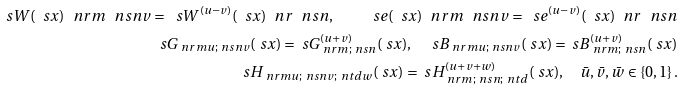Convert formula to latex. <formula><loc_0><loc_0><loc_500><loc_500>\ s W ( \ s x ) _ { \ } n r m ^ { \ } n s n v = \ s W ^ { ( u - v ) } ( \ s x ) _ { \ } n r ^ { \ } n s n , \quad \ s e ( \ s x ) _ { \ } n r m ^ { \ } n s n v = \ s e ^ { ( u - v ) } ( \ s x ) _ { \ } n r ^ { \ } n s n \\ \ s G _ { \ n r m u ; \ n s n v } ( \ s x ) = \ s G _ { \ n r m ; \ n s n } ^ { ( u + v ) } ( \ s x ) , \quad \ s B _ { \ n r m u ; \ n s n v } ( \ s x ) = \ s B _ { \ n r m ; \ n s n } ^ { ( u + v ) } ( \ s x ) \\ \ s H _ { \ n r m u ; \ n s n v ; \ n t d w } ( \ s x ) = \ s H _ { \ n r m ; \ n s n ; \ n t d } ^ { ( u + v + w ) } ( \ s x ) , \quad \bar { u } , \bar { v } , \bar { w } \in \{ 0 , 1 \} \, .</formula> 